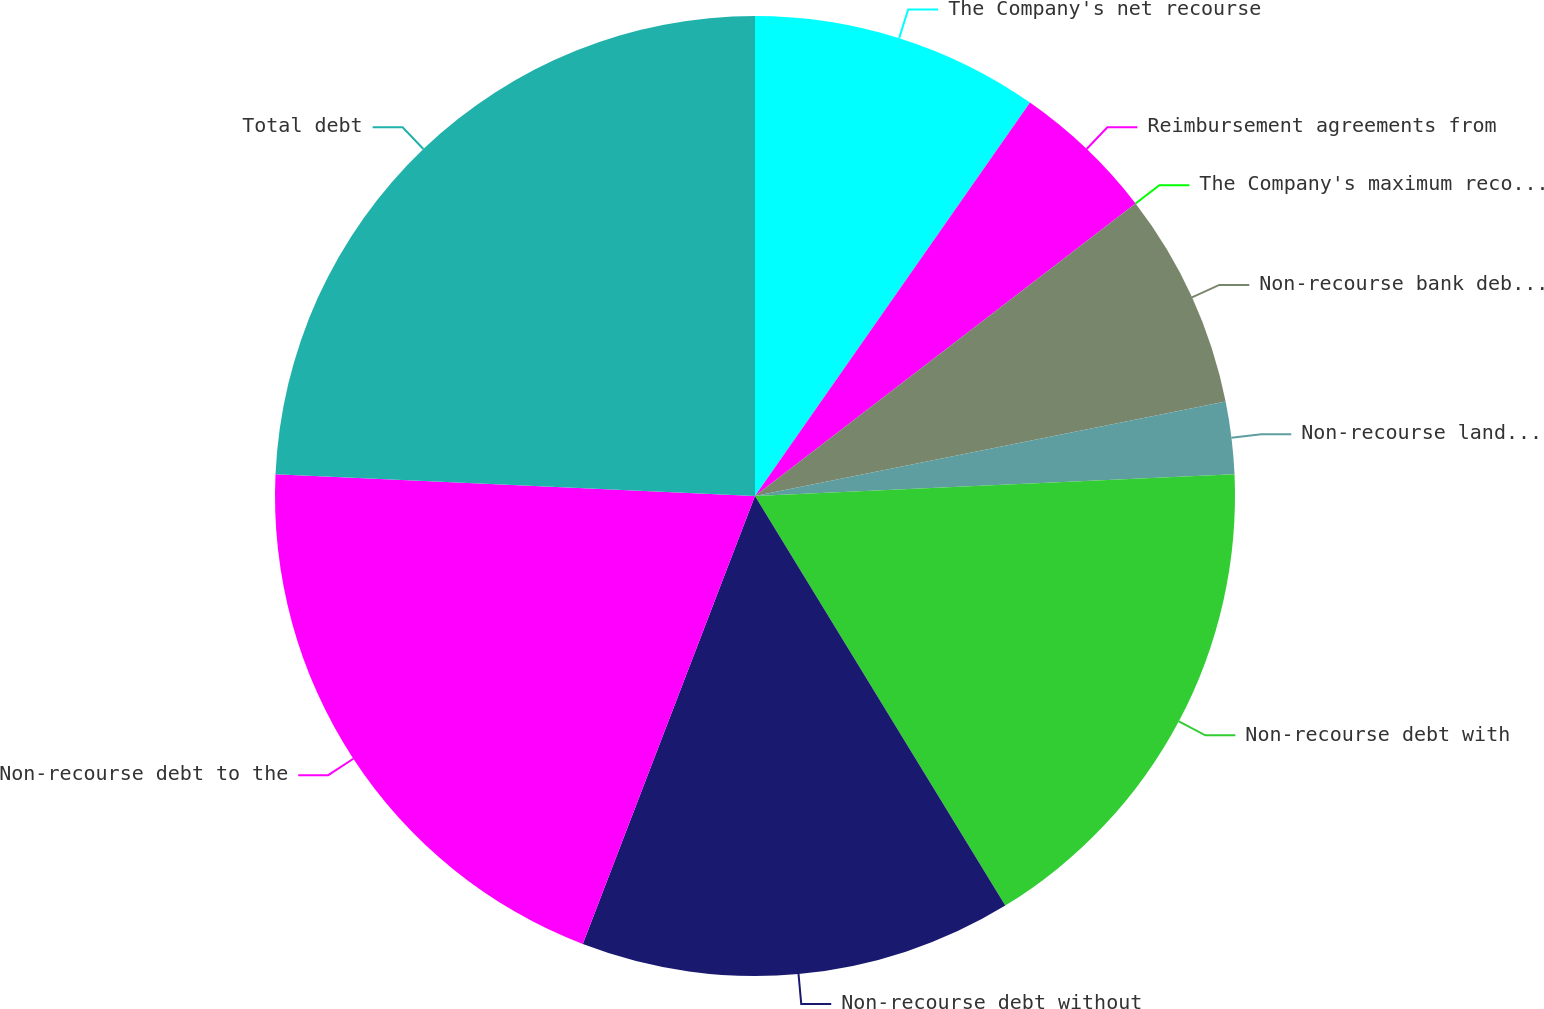Convert chart to OTSL. <chart><loc_0><loc_0><loc_500><loc_500><pie_chart><fcel>The Company's net recourse<fcel>Reimbursement agreements from<fcel>The Company's maximum recourse<fcel>Non-recourse bank debt and<fcel>Non-recourse land seller debt<fcel>Non-recourse debt with<fcel>Non-recourse debt without<fcel>Non-recourse debt to the<fcel>Total debt<nl><fcel>9.71%<fcel>4.86%<fcel>0.0%<fcel>7.28%<fcel>2.43%<fcel>16.99%<fcel>14.57%<fcel>19.88%<fcel>24.28%<nl></chart> 